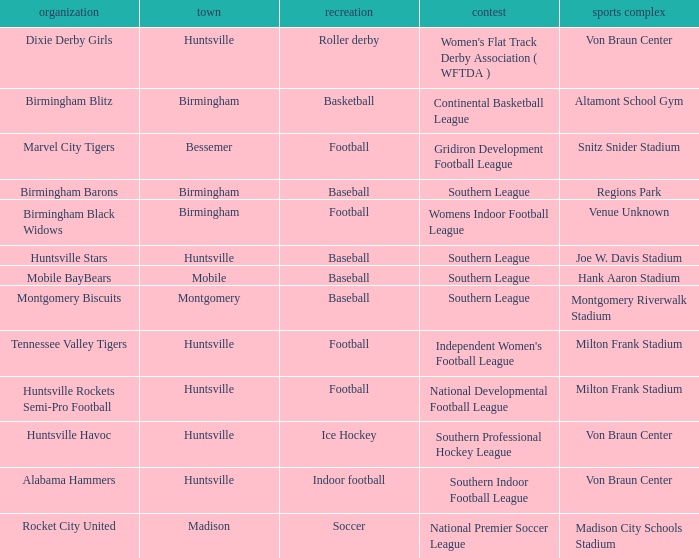Which sport had the club of the Montgomery Biscuits? Baseball. 